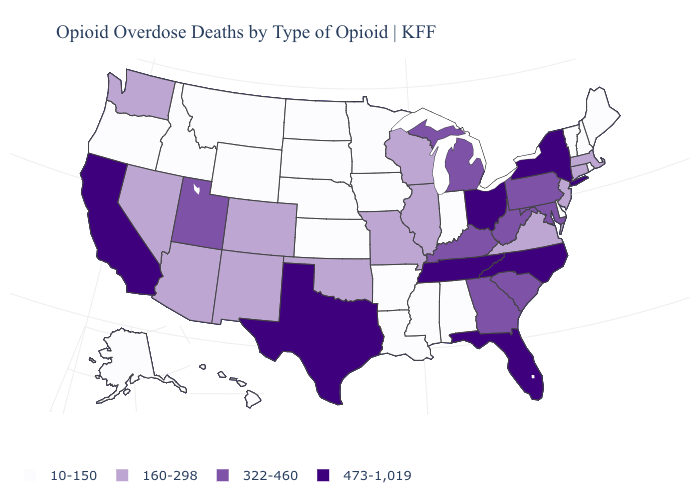Among the states that border Ohio , does Indiana have the lowest value?
Quick response, please. Yes. Name the states that have a value in the range 473-1,019?
Give a very brief answer. California, Florida, New York, North Carolina, Ohio, Tennessee, Texas. Among the states that border Louisiana , does Texas have the highest value?
Short answer required. Yes. Which states have the lowest value in the South?
Be succinct. Alabama, Arkansas, Delaware, Louisiana, Mississippi. What is the lowest value in the USA?
Concise answer only. 10-150. What is the lowest value in the Northeast?
Concise answer only. 10-150. Among the states that border Nevada , which have the lowest value?
Concise answer only. Idaho, Oregon. Does Arizona have a higher value than Oregon?
Quick response, please. Yes. What is the lowest value in the USA?
Keep it brief. 10-150. Among the states that border Mississippi , does Louisiana have the highest value?
Be succinct. No. Does Oregon have a higher value than Arizona?
Short answer required. No. What is the value of Vermont?
Give a very brief answer. 10-150. What is the highest value in the USA?
Answer briefly. 473-1,019. What is the value of South Dakota?
Be succinct. 10-150. What is the value of Hawaii?
Be succinct. 10-150. 